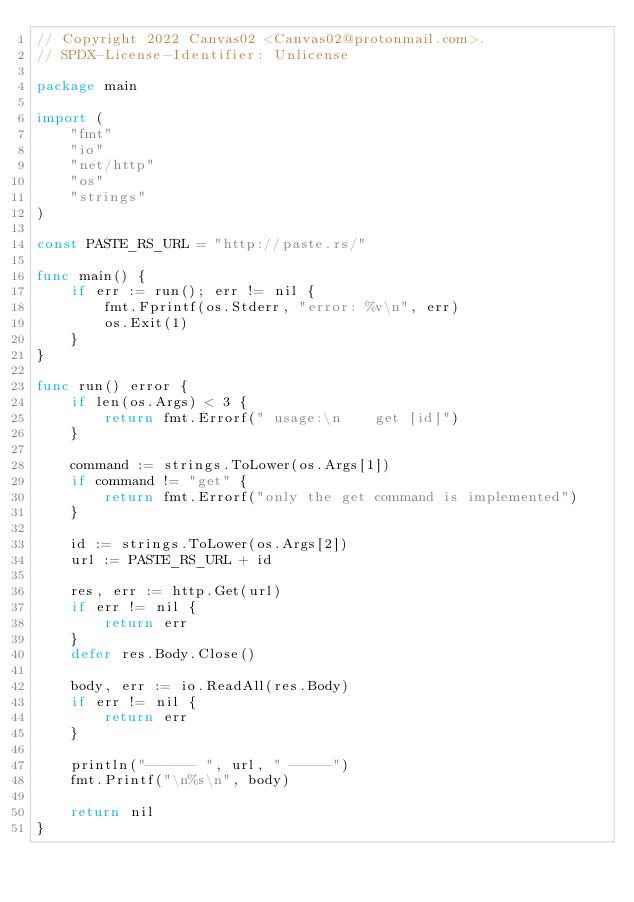<code> <loc_0><loc_0><loc_500><loc_500><_Go_>// Copyright 2022 Canvas02 <Canvas02@protonmail.com>.
// SPDX-License-Identifier: Unlicense

package main

import (
	"fmt"
	"io"
	"net/http"
	"os"
	"strings"
)

const PASTE_RS_URL = "http://paste.rs/"

func main() {
	if err := run(); err != nil {
		fmt.Fprintf(os.Stderr, "error: %v\n", err)
		os.Exit(1)
	}
}

func run() error {
	if len(os.Args) < 3 {
		return fmt.Errorf(" usage:\n    get [id]")
	}

	command := strings.ToLower(os.Args[1])
	if command != "get" {
		return fmt.Errorf("only the get command is implemented")
	}

	id := strings.ToLower(os.Args[2])
	url := PASTE_RS_URL + id

	res, err := http.Get(url)
	if err != nil {
		return err
	}
	defer res.Body.Close()

	body, err := io.ReadAll(res.Body)
	if err != nil {
		return err
	}

	println("------ ", url, " -----")
	fmt.Printf("\n%s\n", body)

	return nil
}
</code> 